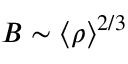Convert formula to latex. <formula><loc_0><loc_0><loc_500><loc_500>B \sim \langle \rho \rangle ^ { 2 / 3 }</formula> 